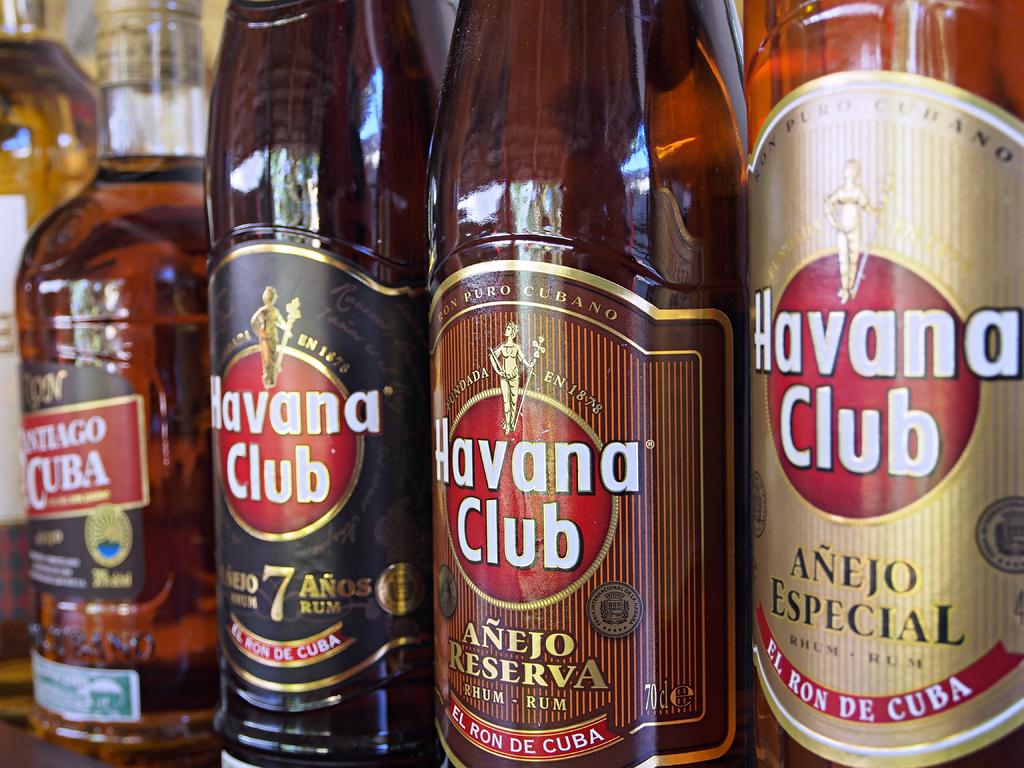What brand of alcohol is this?
Make the answer very short. Havana club. What country is this beer from?
Make the answer very short. Cuba. 